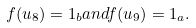<formula> <loc_0><loc_0><loc_500><loc_500>f ( u _ { 8 } ) = 1 _ { b } a n d f ( u _ { 9 } ) = 1 _ { a } .</formula> 